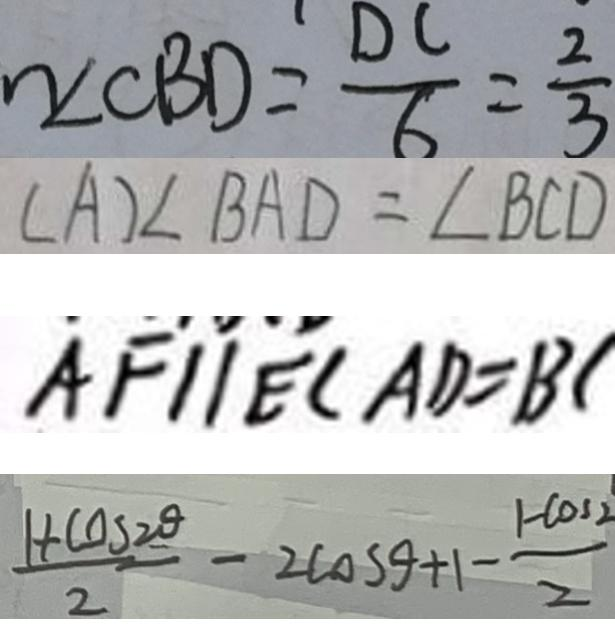<formula> <loc_0><loc_0><loc_500><loc_500>\angle C B D = \frac { D C } { 6 } = \frac { 2 } { 3 } 
 ( A ) \angle B A D = \angle B C D 
 A F / / E C A D = B C 
 \frac { 1 + \cos 2 \theta } { 2 } - 2 \cos \theta + 1 - \frac { 1 - \cos 2 } { 2 }</formula> 